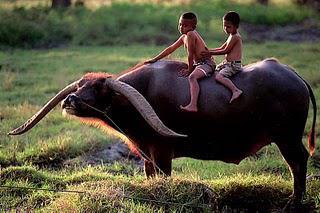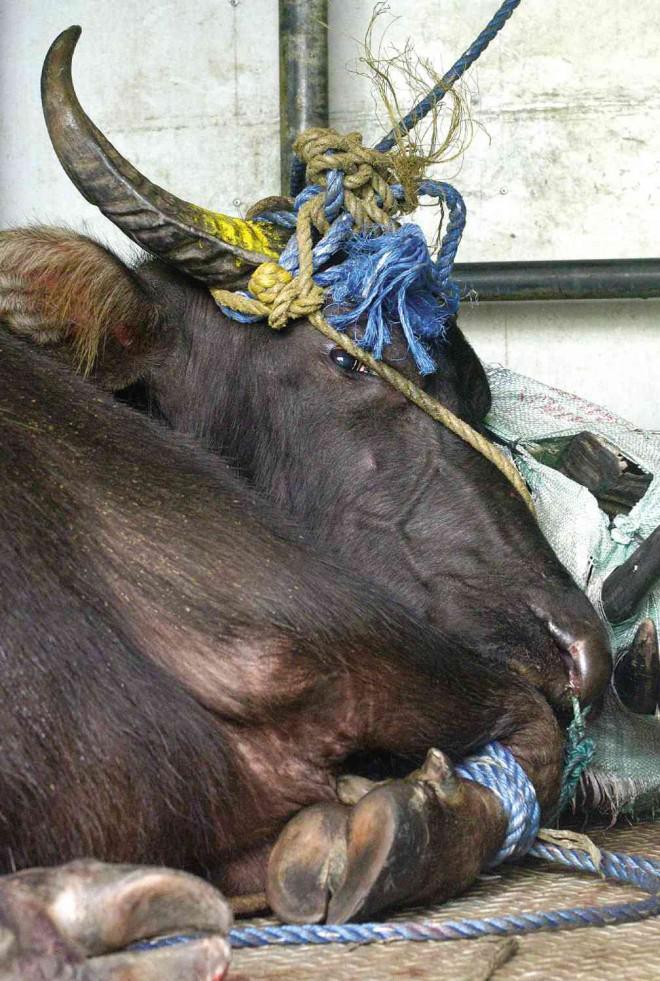The first image is the image on the left, the second image is the image on the right. Evaluate the accuracy of this statement regarding the images: "The left image contains at least two water buffalo.". Is it true? Answer yes or no. No. 